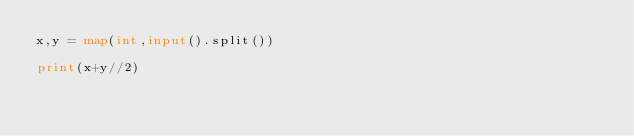Convert code to text. <code><loc_0><loc_0><loc_500><loc_500><_Python_>x,y = map(int,input().split())

print(x+y//2)</code> 